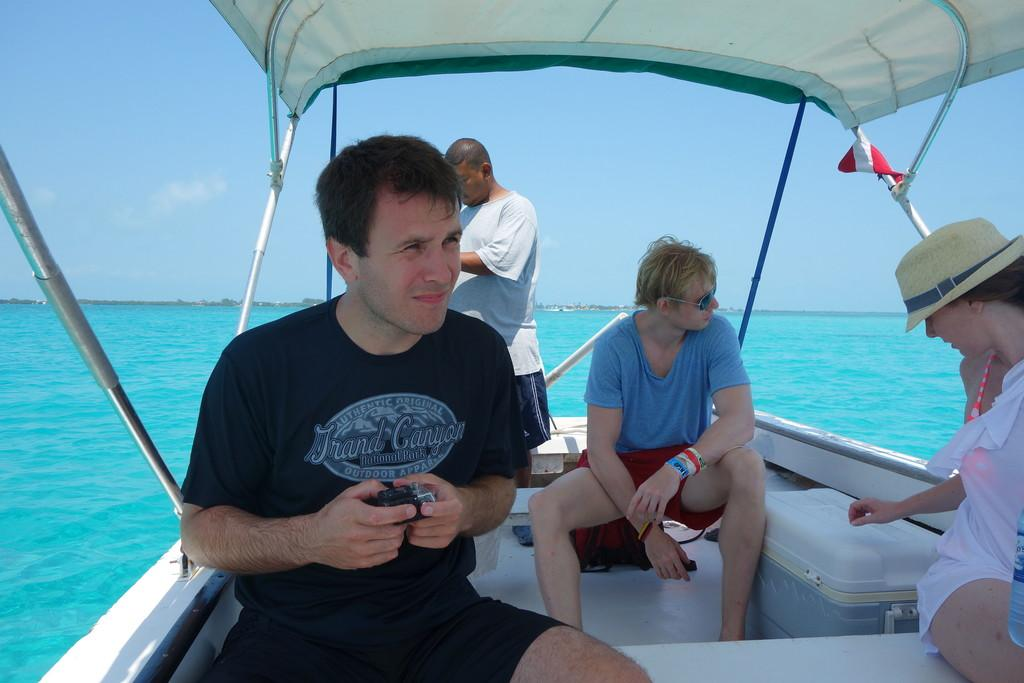What are the people in the image doing? There is a group of people sitting on a boat in the image. Can you describe the position of the man in the image? There is a man standing at the back of the boat. What color is the water in the image? The water in the image is blue. What else can be seen in the image besides the boat and people? The sky is visible in the image. What type of reaction can be seen in the boat's circle in the image? There is no boat's circle present in the image, and therefore no reaction can be observed. 